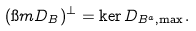<formula> <loc_0><loc_0><loc_500><loc_500>( \i m D _ { B } ) ^ { \perp } = \ker D _ { B ^ { a } , \max } .</formula> 